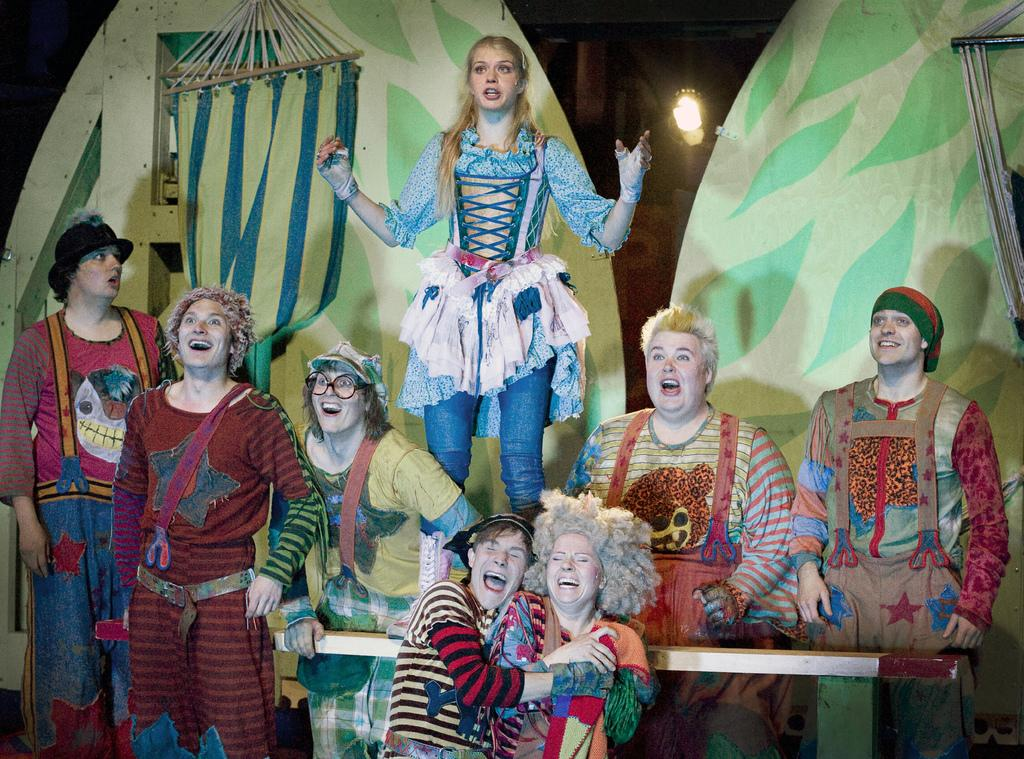What can be seen in the image? There is a group of people in the image. What are the people wearing? The people are wearing multi-color dresses. What is in the background of the image? There is a green-colored board in the background of the image. Can you describe the lighting in the image? There is a light visible in the image. What type of quill is being used by the people in the image? There is no quill present in the image; the people are wearing multi-color dresses. What kind of competition is taking place in the image? There is no competition present in the image; it features a group of people wearing multi-color dresses. 